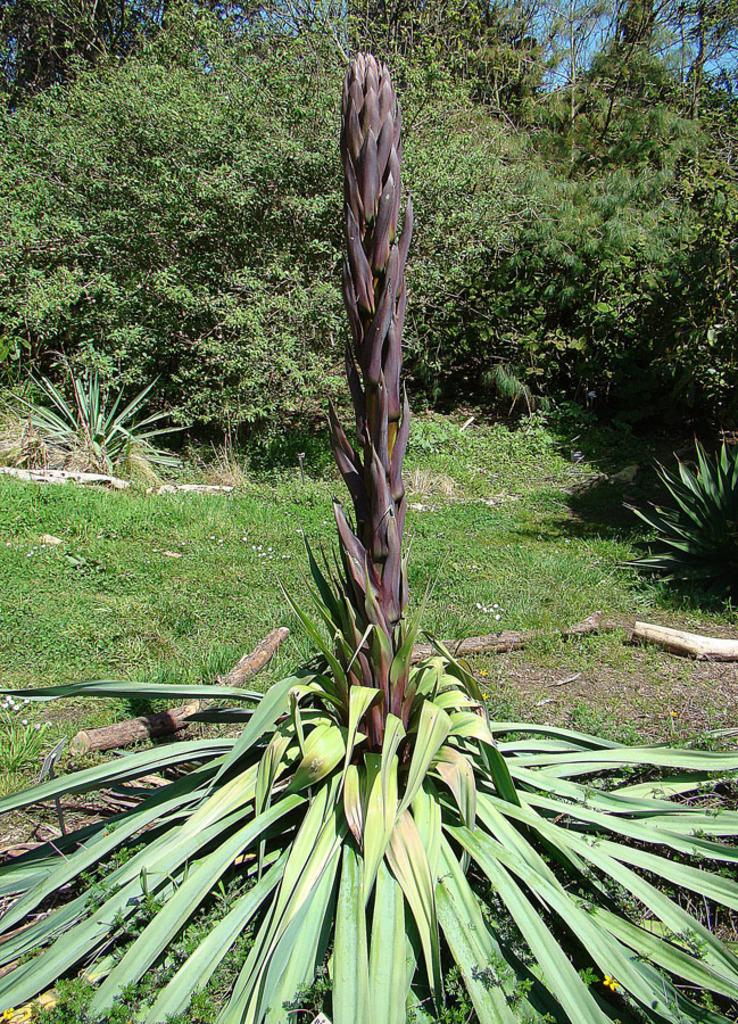What is located in the front of the image? There is a plant in the front of the image. What can be seen in the background of the image? There are trees and grass in the background of the image. What is visible at the top of the image? The sky is visible at the top of the image. What type of meal is being prepared in the image? There is no meal preparation visible in the image; it primarily features a plant, trees, grass, and the sky. 